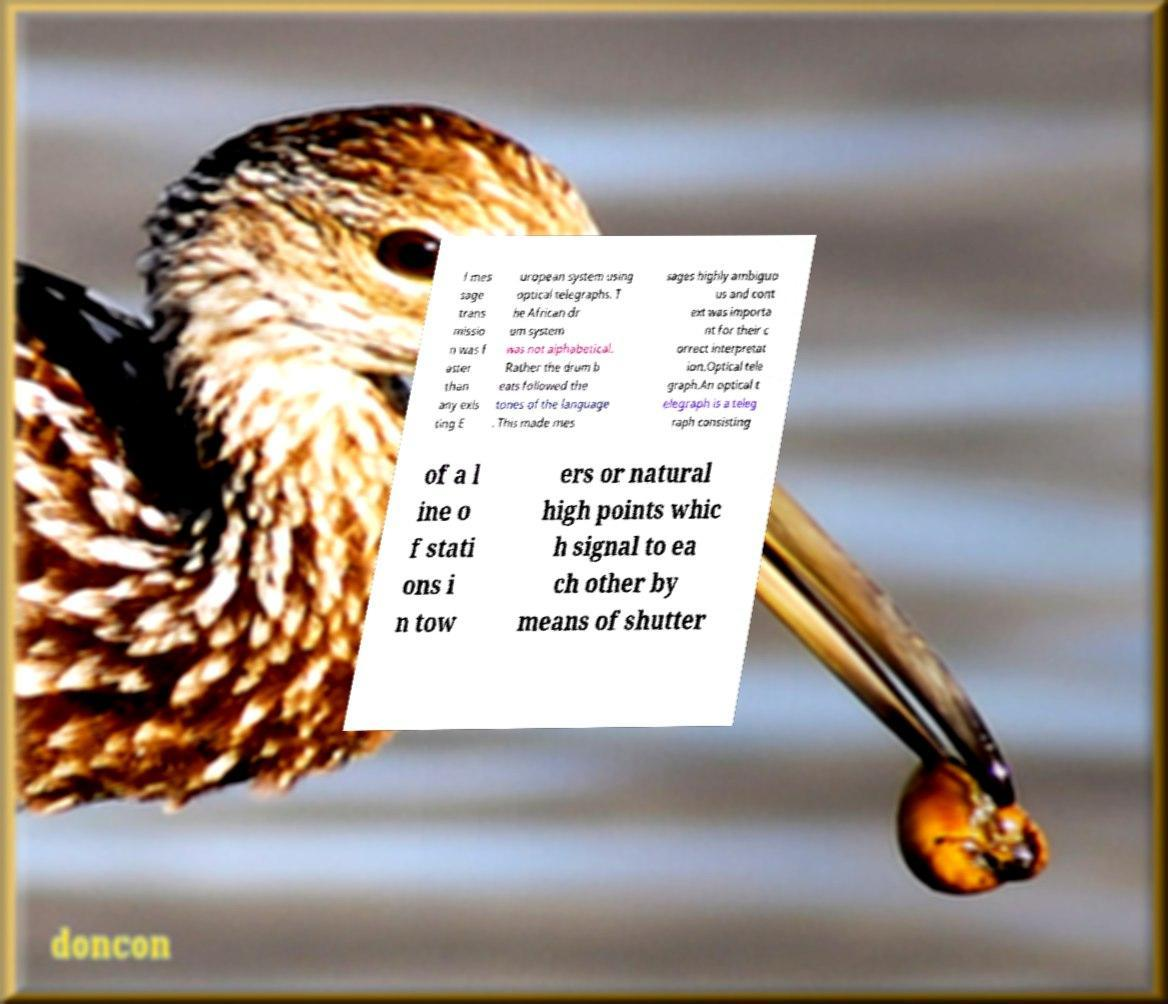For documentation purposes, I need the text within this image transcribed. Could you provide that? f mes sage trans missio n was f aster than any exis ting E uropean system using optical telegraphs. T he African dr um system was not alphabetical. Rather the drum b eats followed the tones of the language . This made mes sages highly ambiguo us and cont ext was importa nt for their c orrect interpretat ion.Optical tele graph.An optical t elegraph is a teleg raph consisting of a l ine o f stati ons i n tow ers or natural high points whic h signal to ea ch other by means of shutter 